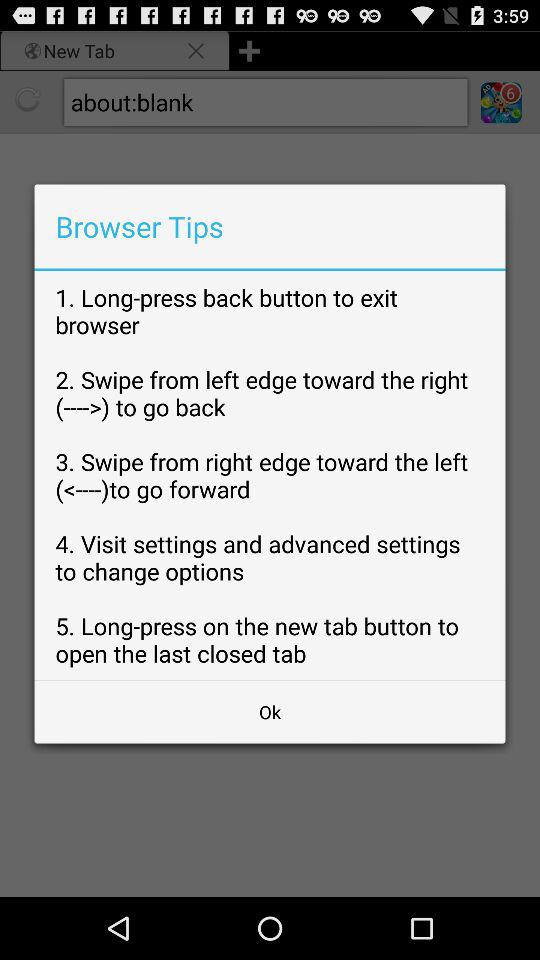How many tips are there in total?
Answer the question using a single word or phrase. 5 